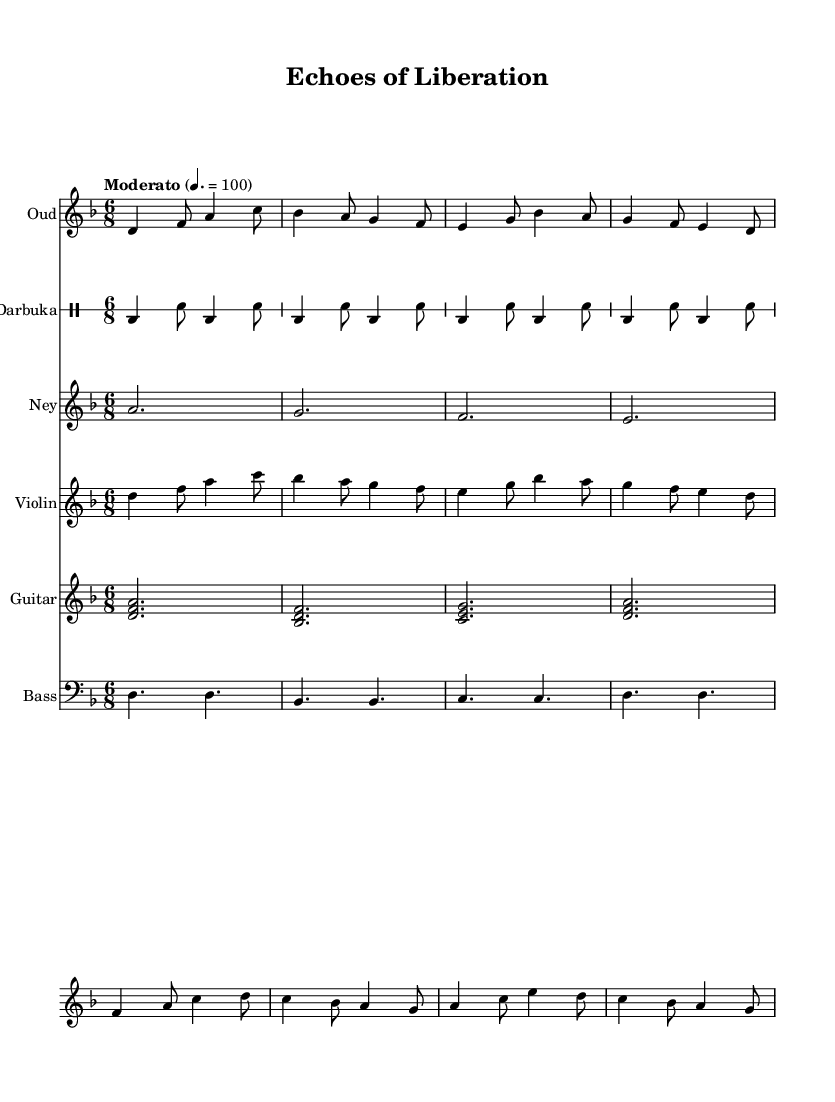What is the key signature of this music? The key signature is indicated by the sharp or flat symbols at the beginning of the staff. In this case, there are no sharps or flats, meaning the key is D minor, which is commonly represented as one flat.
Answer: D minor What is the time signature of this music? The time signature is found at the beginning of the music and indicates the number of beats per measure and the note value representing one beat. Here we see 6/8, which denotes six eighth notes per measure.
Answer: 6/8 What is the tempo marking for this music? The tempo marking is placed above the staff and indicates the speed of the piece. "Moderato" typically suggests a moderate tempo, and it is quantified as a metronome marking of 100 beats per minute in this score.
Answer: Moderato Which traditional North African instrument is featured first in the score? The first staff in the score is labeled "Oud," indicating that it's the first instrument displayed and is a prominent traditional North African string instrument.
Answer: Oud How many sections of darbuka rhythms are present in the score? The score shows a repetitive pattern for the darbuka, which is written with four measures, each containing the same rhythm structure. Since there are four measures of darbuka notated, we count them as four distinct sections.
Answer: Four What is the role of the ney within the score's structure? The ney, represented in the score as a solo instrument that plays sustained notes, complements the rhythms of the other instruments and adds a melodic texture that reflects traditional North African music. It serves an important role in providing a lyrical element.
Answer: Melodic texture What dynamic level is suggested throughout the score? The score does not indicate specific dynamics such as forte or piano, which suggests a more general performance style. However, since the piece has no extreme dynamics specified, it typically implies a moderate dynamic level across all sections.
Answer: Moderate 